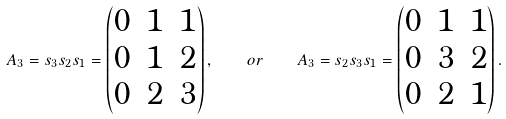<formula> <loc_0><loc_0><loc_500><loc_500>A _ { 3 } = s _ { 3 } s _ { 2 } s _ { 1 } = \begin{pmatrix} 0 & 1 & 1 \\ 0 & 1 & 2 \\ 0 & 2 & 3 \end{pmatrix} , \quad o r \quad A _ { 3 } = s _ { 2 } s _ { 3 } s _ { 1 } = \begin{pmatrix} 0 & 1 & 1 \\ 0 & 3 & 2 \\ 0 & 2 & 1 \end{pmatrix} .</formula> 